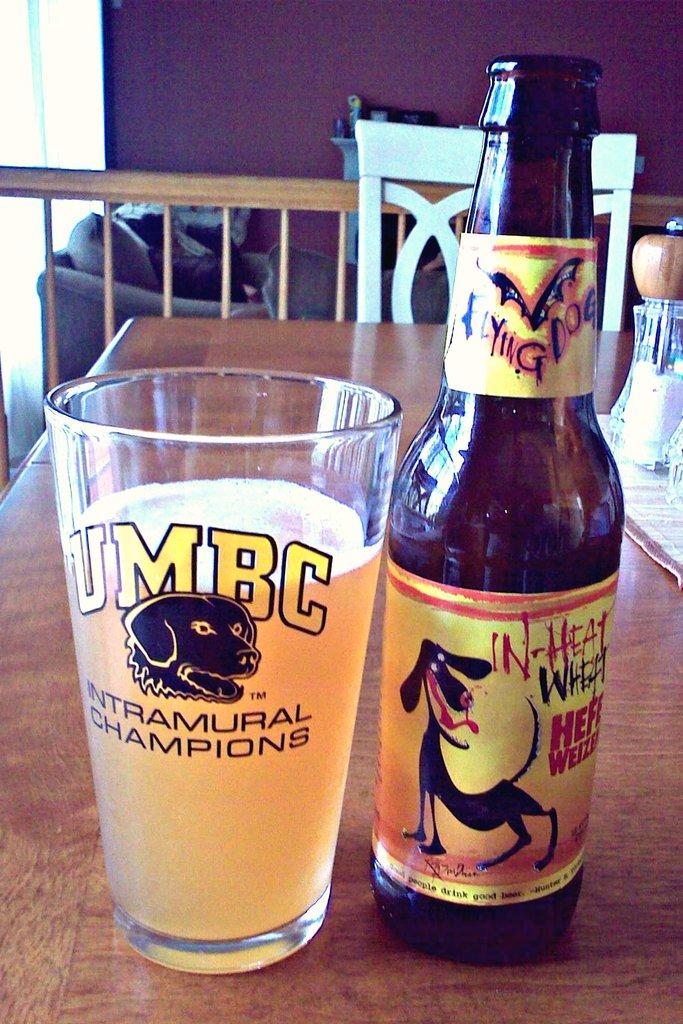<image>
Provide a brief description of the given image. A bottle of in-heat wheat poured into a UMBC glass 